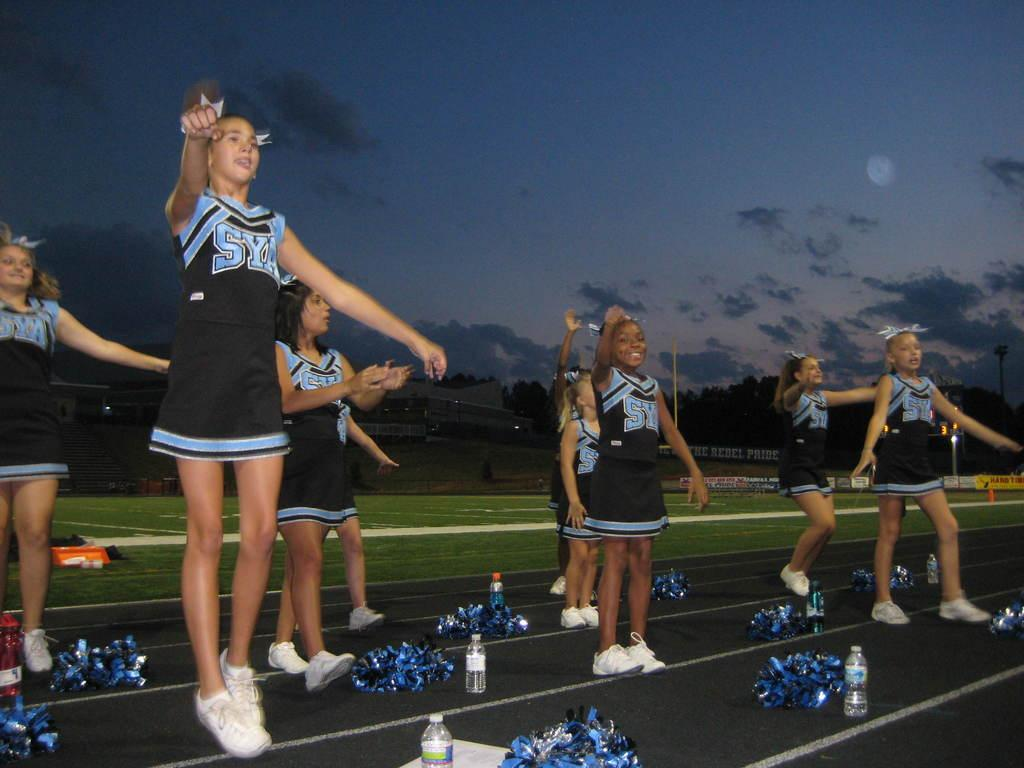Provide a one-sentence caption for the provided image. A group of cheerleaders from the school SYA. 